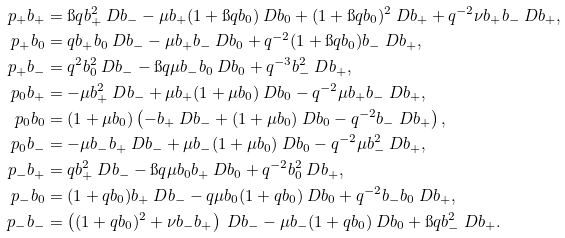Convert formula to latex. <formula><loc_0><loc_0><loc_500><loc_500>\ p _ { + } b _ { + } & = \i q b _ { + } ^ { 2 } \ D b _ { - } - \mu b _ { + } ( 1 + \i q b _ { 0 } ) \ D b _ { 0 } + ( 1 + \i q b _ { 0 } ) ^ { 2 } \ D b _ { + } + q ^ { - 2 } \nu b _ { + } b _ { - } \ D b _ { + } , \\ \ p _ { + } b _ { 0 } & = q b _ { + } b _ { 0 } \ D b _ { - } - \mu b _ { + } b _ { - } \ D b _ { 0 } + q ^ { - 2 } ( 1 + \i q b _ { 0 } ) b _ { - } \ D b _ { + } , \\ \ p _ { + } b _ { - } & = q ^ { 2 } b _ { 0 } ^ { 2 } \ D b _ { - } - \i q \mu b _ { - } b _ { 0 } \ D b _ { 0 } + q ^ { - 3 } b _ { - } ^ { 2 } \ D b _ { + } , \\ \ p _ { 0 } b _ { + } & = - \mu b _ { + } ^ { 2 } \ D b _ { - } + \mu b _ { + } ( 1 + \mu b _ { 0 } ) \ D b _ { 0 } - q ^ { - 2 } \mu b _ { + } b _ { - } \ D b _ { + } , \\ \ p _ { 0 } b _ { 0 } & = ( 1 + \mu b _ { 0 } ) \left ( - b _ { + } \ D b _ { - } + ( 1 + \mu b _ { 0 } ) \ D b _ { 0 } - q ^ { - 2 } b _ { - } \ D b _ { + } \right ) , \\ \ p _ { 0 } b _ { - } & = - \mu b _ { - } b _ { + } \ D b _ { - } + \mu b _ { - } ( 1 + \mu b _ { 0 } ) \ D b _ { 0 } - q ^ { - 2 } \mu b _ { - } ^ { 2 } \ D b _ { + } , \\ \ p _ { - } b _ { + } & = q b _ { + } ^ { 2 } \ D b _ { - } - \i q \mu b _ { 0 } b _ { + } \ D b _ { 0 } + q ^ { - 2 } b _ { 0 } ^ { 2 } \ D b _ { + } , \\ \ p _ { - } b _ { 0 } & = ( 1 + q b _ { 0 } ) b _ { + } \ D b _ { - } - q \mu b _ { 0 } ( 1 + q b _ { 0 } ) \ D b _ { 0 } + q ^ { - 2 } b _ { - } b _ { 0 } \ D b _ { + } , \\ \ p _ { - } b _ { - } & = \left ( ( 1 + q b _ { 0 } ) ^ { 2 } + \nu b _ { - } b _ { + } \right ) \ D b _ { - } - \mu b _ { - } ( 1 + q b _ { 0 } ) \ D b _ { 0 } + \i q b _ { - } ^ { 2 } \ D b _ { + } .</formula> 